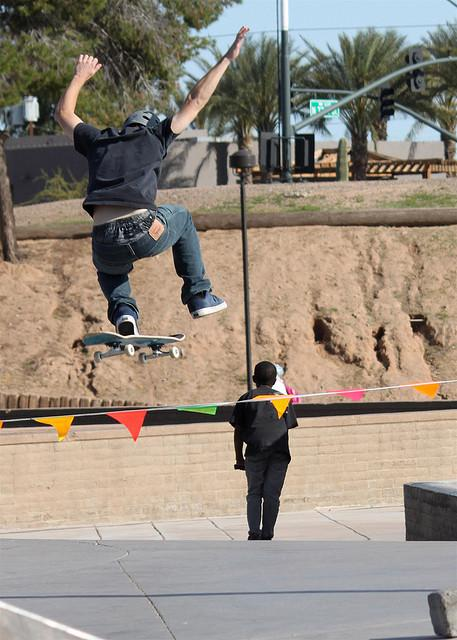In what setting is the skater skating?

Choices:
A) desert
B) oceanic
C) farm
D) urban urban 